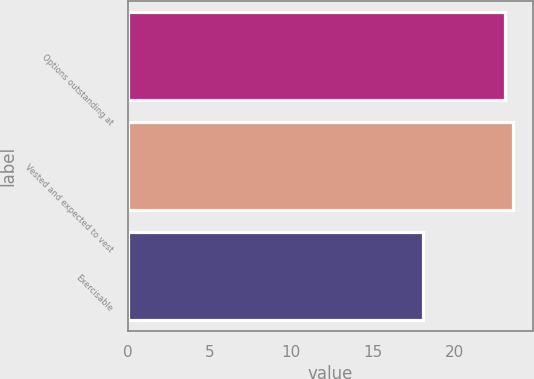Convert chart. <chart><loc_0><loc_0><loc_500><loc_500><bar_chart><fcel>Options outstanding at<fcel>Vested and expected to vest<fcel>Exercisable<nl><fcel>23.1<fcel>23.6<fcel>18.1<nl></chart> 